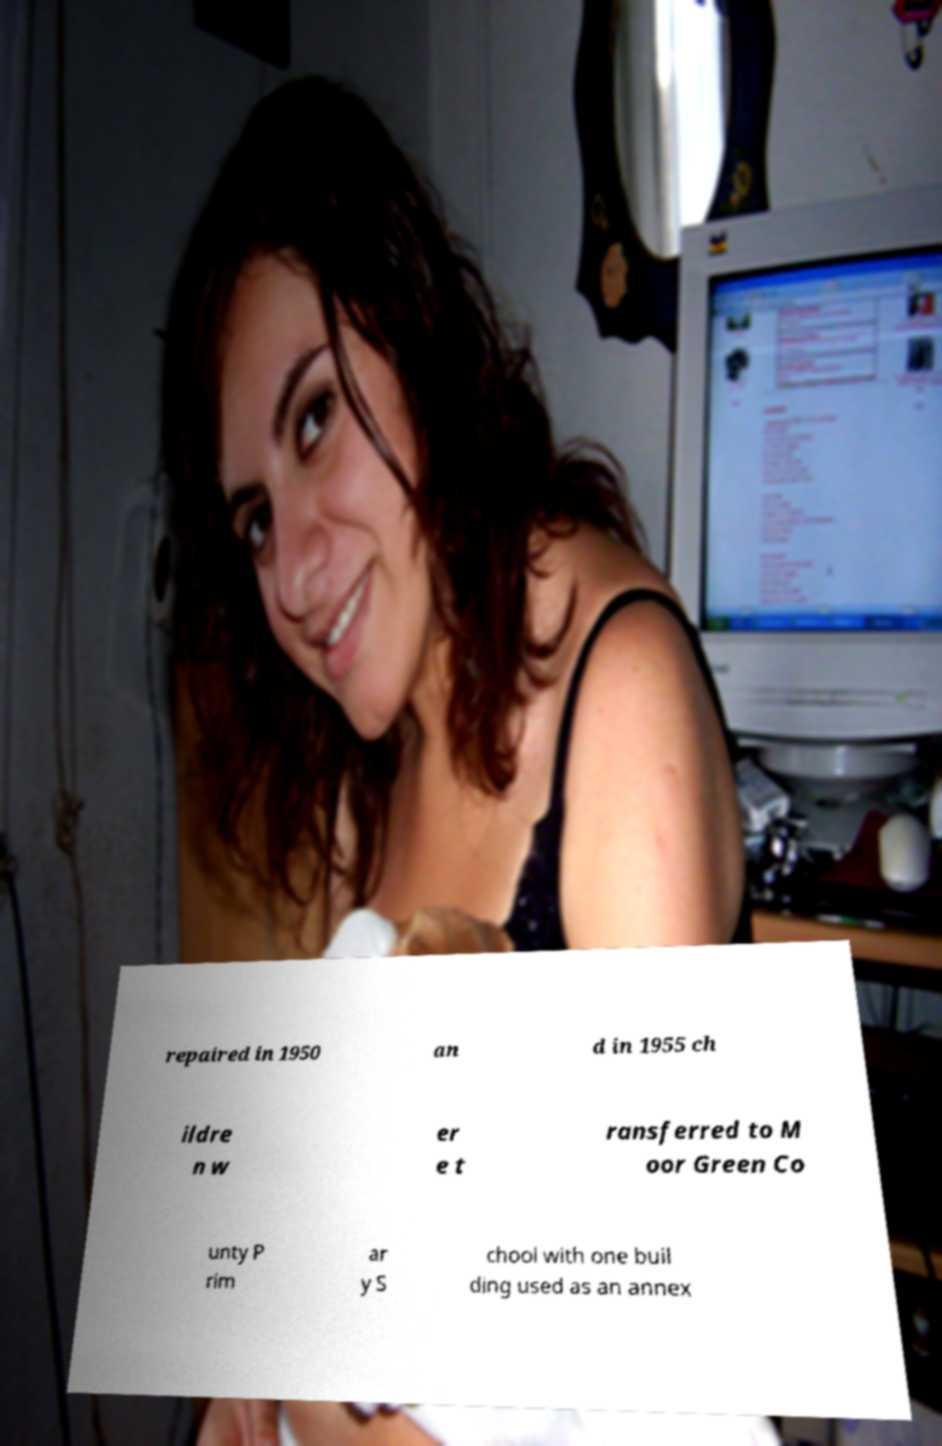I need the written content from this picture converted into text. Can you do that? repaired in 1950 an d in 1955 ch ildre n w er e t ransferred to M oor Green Co unty P rim ar y S chool with one buil ding used as an annex 